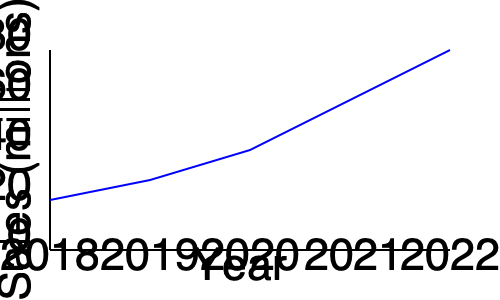Based on the line chart showing audiobook sales growth from 2018 to 2022, what was the approximate percentage increase in sales between 2018 and 2022? To calculate the percentage increase in audiobook sales between 2018 and 2022:

1. Determine the sales values:
   2018: Approximately 20 million
   2022: Approximately 80 million

2. Calculate the difference:
   $80 - 20 = 60$ million

3. Divide the increase by the initial value:
   $\frac{60}{20} = 3$

4. Convert to percentage:
   $3 \times 100\% = 300\%$

The sales increased by approximately 300% from 2018 to 2022.
Answer: 300% 